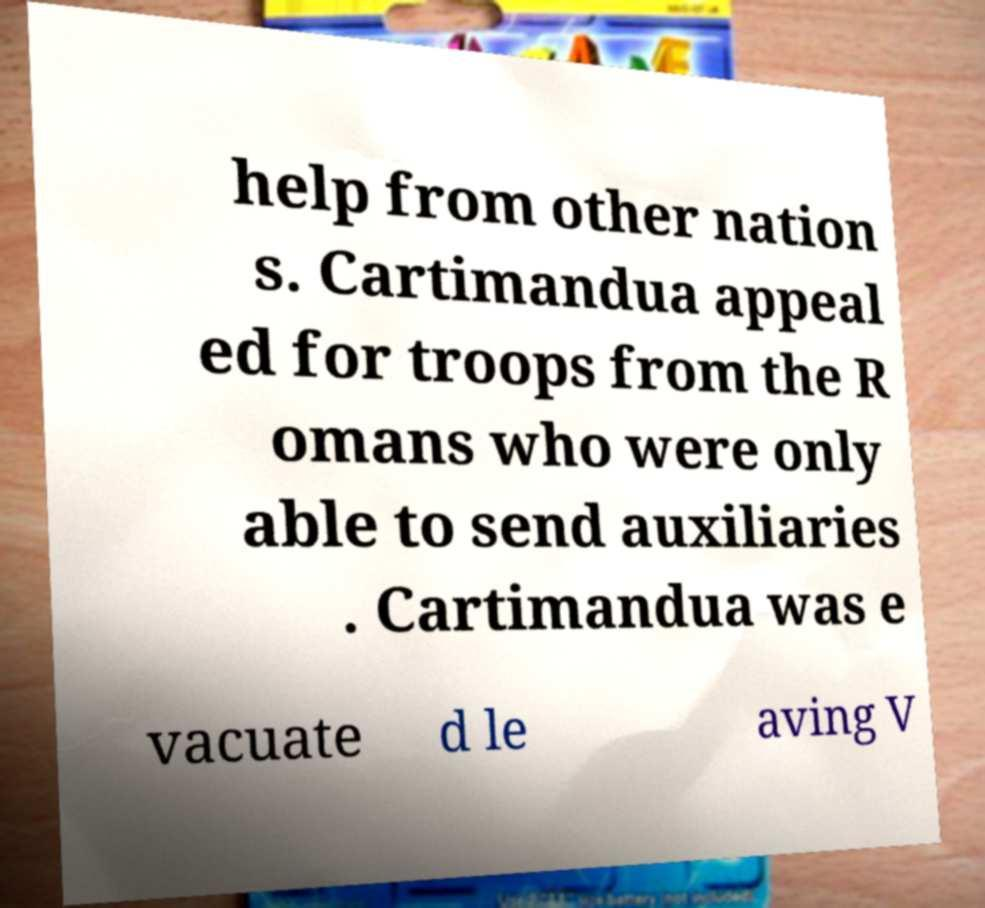What messages or text are displayed in this image? I need them in a readable, typed format. help from other nation s. Cartimandua appeal ed for troops from the R omans who were only able to send auxiliaries . Cartimandua was e vacuate d le aving V 